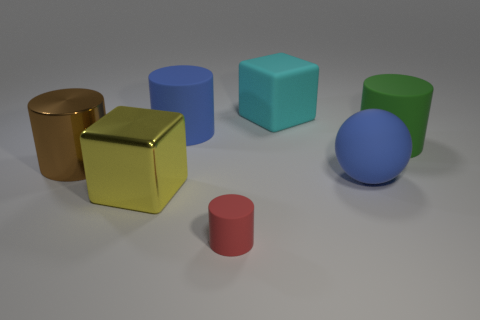Subtract all large cylinders. How many cylinders are left? 1 Add 3 green matte things. How many objects exist? 10 Subtract all cyan blocks. How many blocks are left? 1 Subtract 0 purple spheres. How many objects are left? 7 Subtract all blocks. How many objects are left? 5 Subtract 2 cubes. How many cubes are left? 0 Subtract all red balls. Subtract all red cylinders. How many balls are left? 1 Subtract all cyan rubber objects. Subtract all rubber cubes. How many objects are left? 5 Add 6 large matte things. How many large matte things are left? 10 Add 7 big cyan rubber blocks. How many big cyan rubber blocks exist? 8 